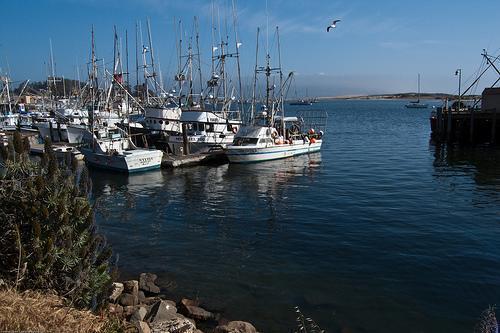How many birds are in the air?
Give a very brief answer. 1. 